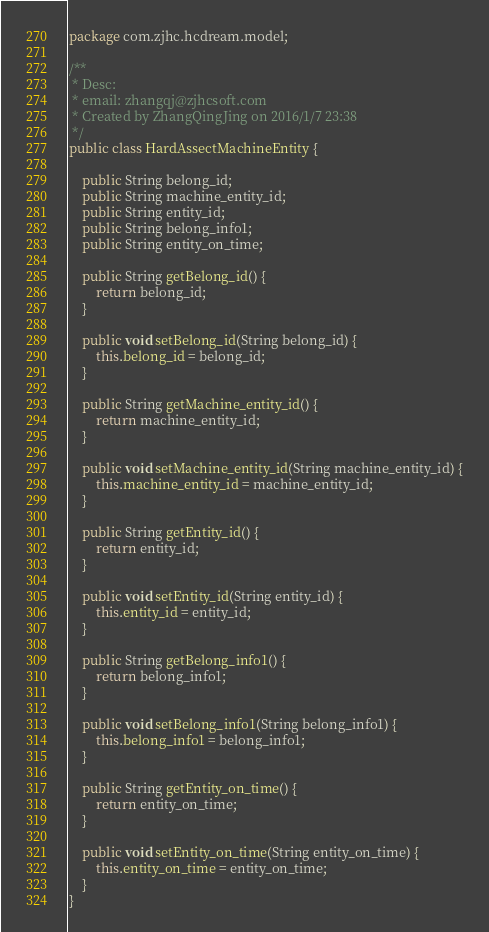<code> <loc_0><loc_0><loc_500><loc_500><_Java_>package com.zjhc.hcdream.model;

/**
 * Desc:
 * email: zhangqj@zjhcsoft.com
 * Created by ZhangQingJing on 2016/1/7 23:38
 */
public class HardAssectMachineEntity {

    public String belong_id;
    public String machine_entity_id;
    public String entity_id;
    public String belong_info1;
    public String entity_on_time;

    public String getBelong_id() {
        return belong_id;
    }

    public void setBelong_id(String belong_id) {
        this.belong_id = belong_id;
    }

    public String getMachine_entity_id() {
        return machine_entity_id;
    }

    public void setMachine_entity_id(String machine_entity_id) {
        this.machine_entity_id = machine_entity_id;
    }

    public String getEntity_id() {
        return entity_id;
    }

    public void setEntity_id(String entity_id) {
        this.entity_id = entity_id;
    }

    public String getBelong_info1() {
        return belong_info1;
    }

    public void setBelong_info1(String belong_info1) {
        this.belong_info1 = belong_info1;
    }

    public String getEntity_on_time() {
        return entity_on_time;
    }

    public void setEntity_on_time(String entity_on_time) {
        this.entity_on_time = entity_on_time;
    }
}
</code> 